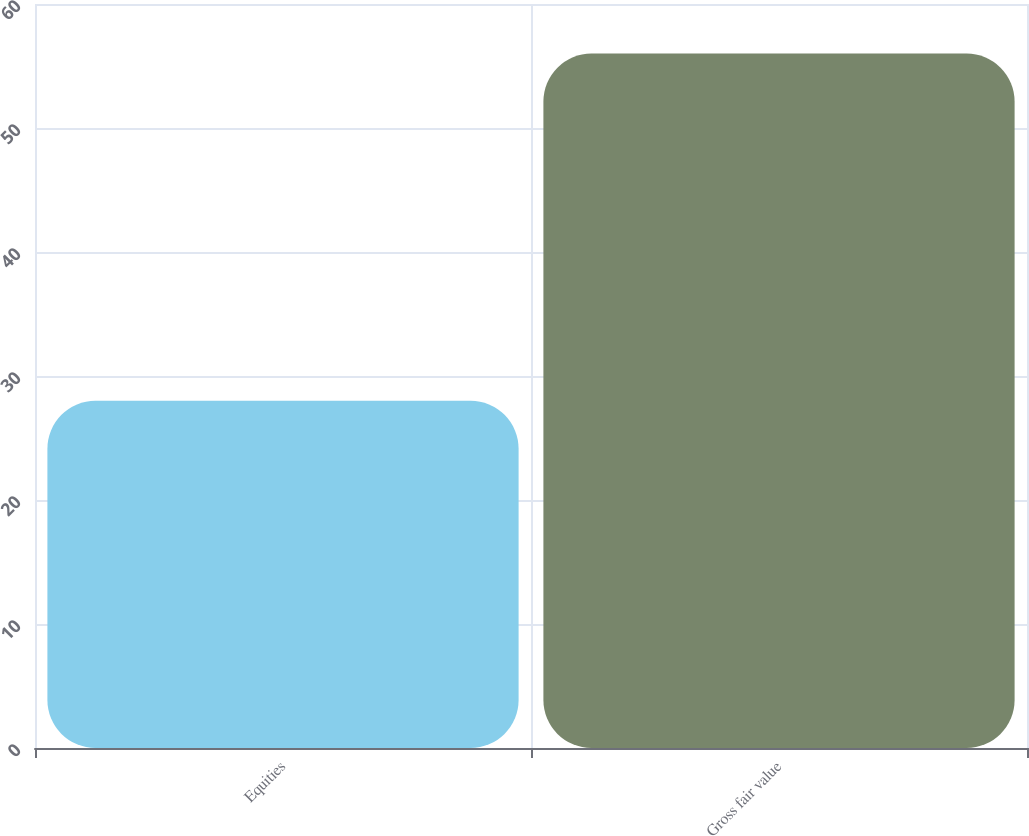Convert chart. <chart><loc_0><loc_0><loc_500><loc_500><bar_chart><fcel>Equities<fcel>Gross fair value<nl><fcel>28<fcel>56<nl></chart> 